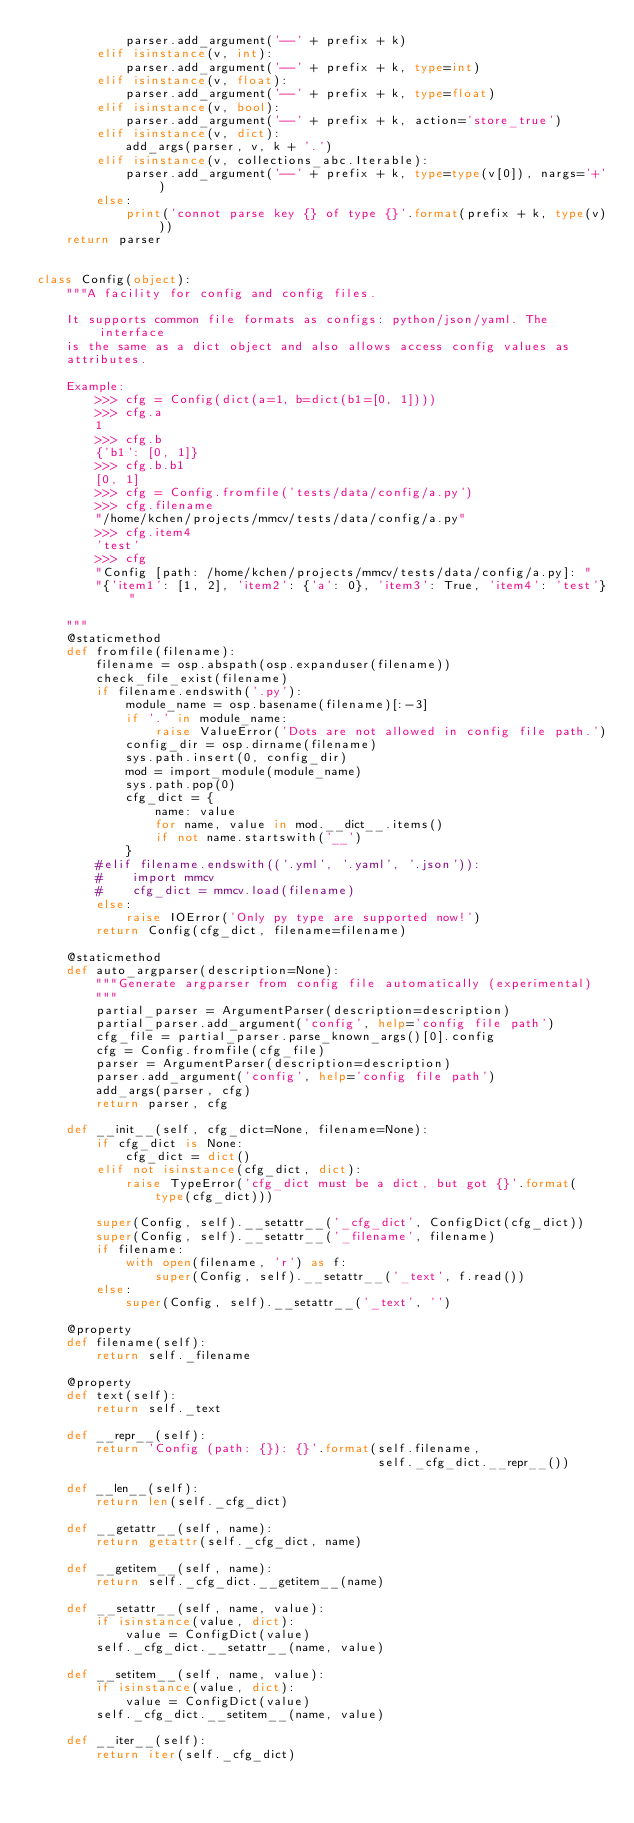<code> <loc_0><loc_0><loc_500><loc_500><_Python_>            parser.add_argument('--' + prefix + k)
        elif isinstance(v, int):
            parser.add_argument('--' + prefix + k, type=int)
        elif isinstance(v, float):
            parser.add_argument('--' + prefix + k, type=float)
        elif isinstance(v, bool):
            parser.add_argument('--' + prefix + k, action='store_true')
        elif isinstance(v, dict):
            add_args(parser, v, k + '.')
        elif isinstance(v, collections_abc.Iterable):
            parser.add_argument('--' + prefix + k, type=type(v[0]), nargs='+')
        else:
            print('connot parse key {} of type {}'.format(prefix + k, type(v)))
    return parser


class Config(object):
    """A facility for config and config files.

    It supports common file formats as configs: python/json/yaml. The interface
    is the same as a dict object and also allows access config values as
    attributes.

    Example:
        >>> cfg = Config(dict(a=1, b=dict(b1=[0, 1])))
        >>> cfg.a
        1
        >>> cfg.b
        {'b1': [0, 1]}
        >>> cfg.b.b1
        [0, 1]
        >>> cfg = Config.fromfile('tests/data/config/a.py')
        >>> cfg.filename
        "/home/kchen/projects/mmcv/tests/data/config/a.py"
        >>> cfg.item4
        'test'
        >>> cfg
        "Config [path: /home/kchen/projects/mmcv/tests/data/config/a.py]: "
        "{'item1': [1, 2], 'item2': {'a': 0}, 'item3': True, 'item4': 'test'}"

    """
    @staticmethod
    def fromfile(filename):
        filename = osp.abspath(osp.expanduser(filename))
        check_file_exist(filename)
        if filename.endswith('.py'):
            module_name = osp.basename(filename)[:-3]
            if '.' in module_name:
                raise ValueError('Dots are not allowed in config file path.')
            config_dir = osp.dirname(filename)
            sys.path.insert(0, config_dir)
            mod = import_module(module_name)
            sys.path.pop(0)
            cfg_dict = {
                name: value
                for name, value in mod.__dict__.items()
                if not name.startswith('__')
            }
        #elif filename.endswith(('.yml', '.yaml', '.json')):
        #    import mmcv
        #    cfg_dict = mmcv.load(filename)
        else:
            raise IOError('Only py type are supported now!')
        return Config(cfg_dict, filename=filename)

    @staticmethod
    def auto_argparser(description=None):
        """Generate argparser from config file automatically (experimental)
        """
        partial_parser = ArgumentParser(description=description)
        partial_parser.add_argument('config', help='config file path')
        cfg_file = partial_parser.parse_known_args()[0].config
        cfg = Config.fromfile(cfg_file)
        parser = ArgumentParser(description=description)
        parser.add_argument('config', help='config file path')
        add_args(parser, cfg)
        return parser, cfg

    def __init__(self, cfg_dict=None, filename=None):
        if cfg_dict is None:
            cfg_dict = dict()
        elif not isinstance(cfg_dict, dict):
            raise TypeError('cfg_dict must be a dict, but got {}'.format(
                type(cfg_dict)))

        super(Config, self).__setattr__('_cfg_dict', ConfigDict(cfg_dict))
        super(Config, self).__setattr__('_filename', filename)
        if filename:
            with open(filename, 'r') as f:
                super(Config, self).__setattr__('_text', f.read())
        else:
            super(Config, self).__setattr__('_text', '')

    @property
    def filename(self):
        return self._filename

    @property
    def text(self):
        return self._text

    def __repr__(self):
        return 'Config (path: {}): {}'.format(self.filename,
                                              self._cfg_dict.__repr__())

    def __len__(self):
        return len(self._cfg_dict)

    def __getattr__(self, name):
        return getattr(self._cfg_dict, name)

    def __getitem__(self, name):
        return self._cfg_dict.__getitem__(name)

    def __setattr__(self, name, value):
        if isinstance(value, dict):
            value = ConfigDict(value)
        self._cfg_dict.__setattr__(name, value)

    def __setitem__(self, name, value):
        if isinstance(value, dict):
            value = ConfigDict(value)
        self._cfg_dict.__setitem__(name, value)

    def __iter__(self):
        return iter(self._cfg_dict)
</code> 